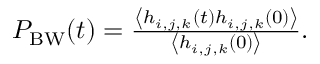Convert formula to latex. <formula><loc_0><loc_0><loc_500><loc_500>\begin{array} { r } { P _ { B W } ( t ) = \frac { \left \langle h _ { i , j , k } ( t ) h _ { i , j , k } ( 0 ) \right \rangle } { \left \langle h _ { i , j , k } ( 0 ) \right \rangle } . } \end{array}</formula> 